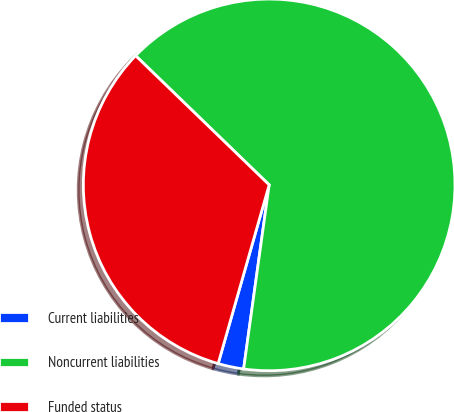Convert chart. <chart><loc_0><loc_0><loc_500><loc_500><pie_chart><fcel>Current liabilities<fcel>Noncurrent liabilities<fcel>Funded status<nl><fcel>2.23%<fcel>64.96%<fcel>32.81%<nl></chart> 